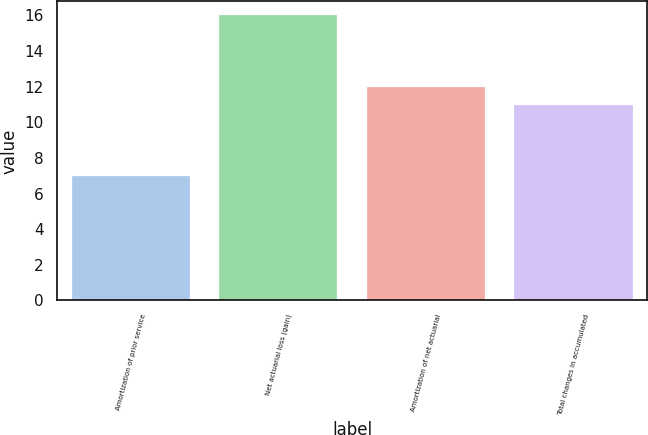Convert chart to OTSL. <chart><loc_0><loc_0><loc_500><loc_500><bar_chart><fcel>Amortization of prior service<fcel>Net actuarial loss (gain)<fcel>Amortization of net actuarial<fcel>Total changes in accumulated<nl><fcel>7<fcel>16<fcel>12<fcel>11<nl></chart> 